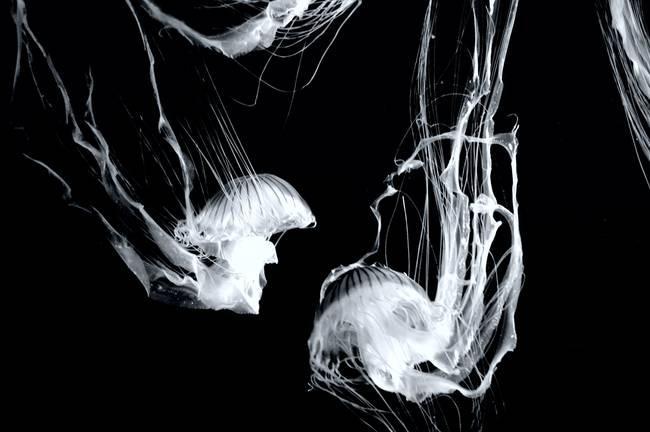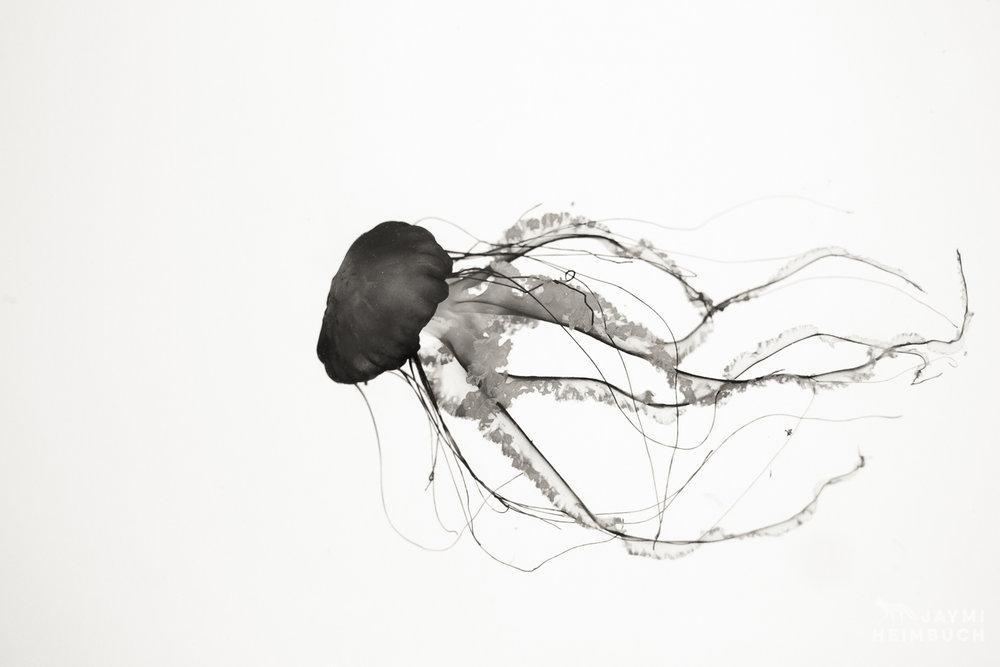The first image is the image on the left, the second image is the image on the right. For the images displayed, is the sentence "The image on the right shows only a single jellyfish swimming to the right." factually correct? Answer yes or no. No. 